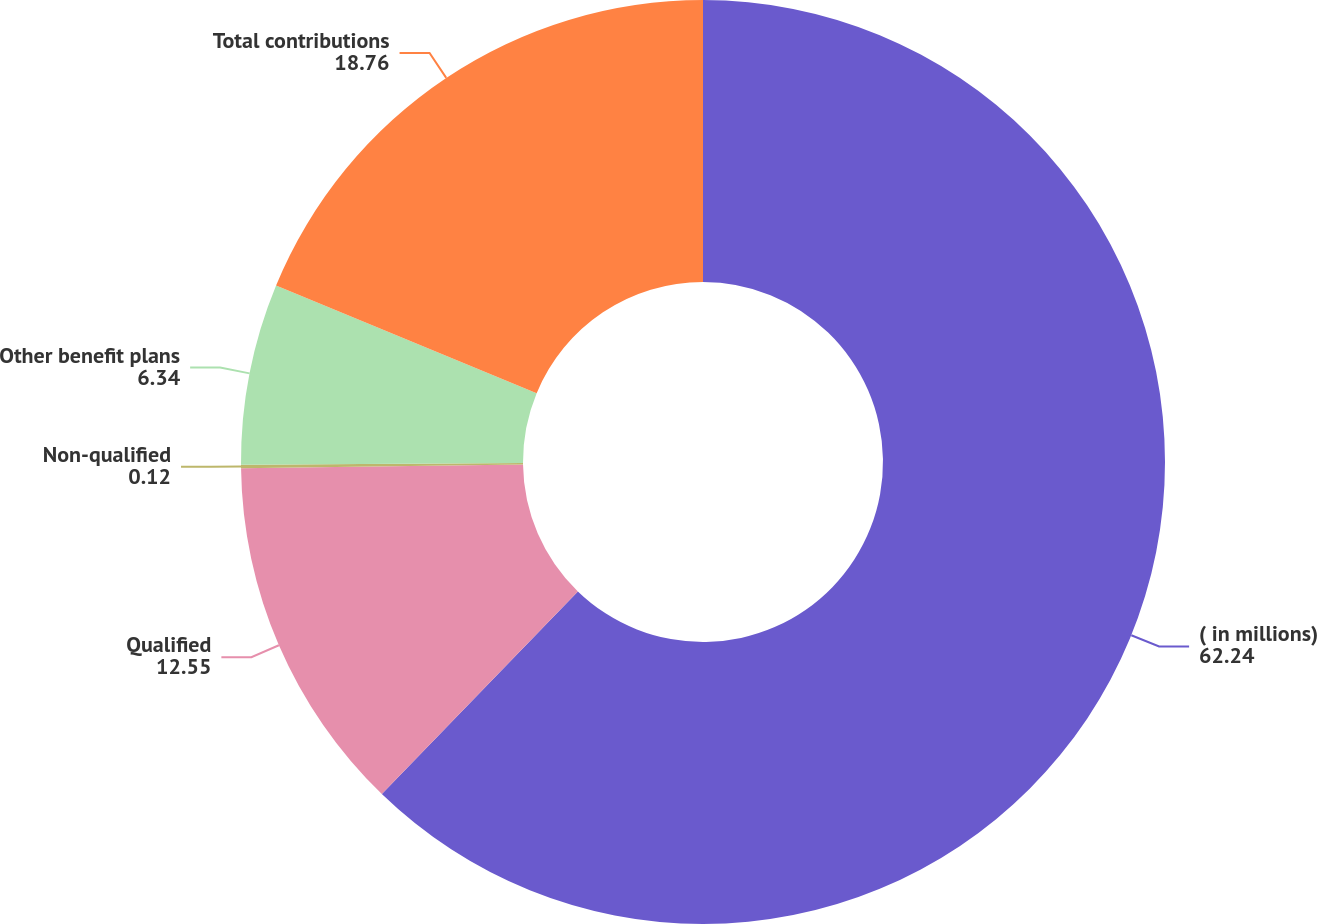Convert chart. <chart><loc_0><loc_0><loc_500><loc_500><pie_chart><fcel>( in millions)<fcel>Qualified<fcel>Non-qualified<fcel>Other benefit plans<fcel>Total contributions<nl><fcel>62.24%<fcel>12.55%<fcel>0.12%<fcel>6.34%<fcel>18.76%<nl></chart> 